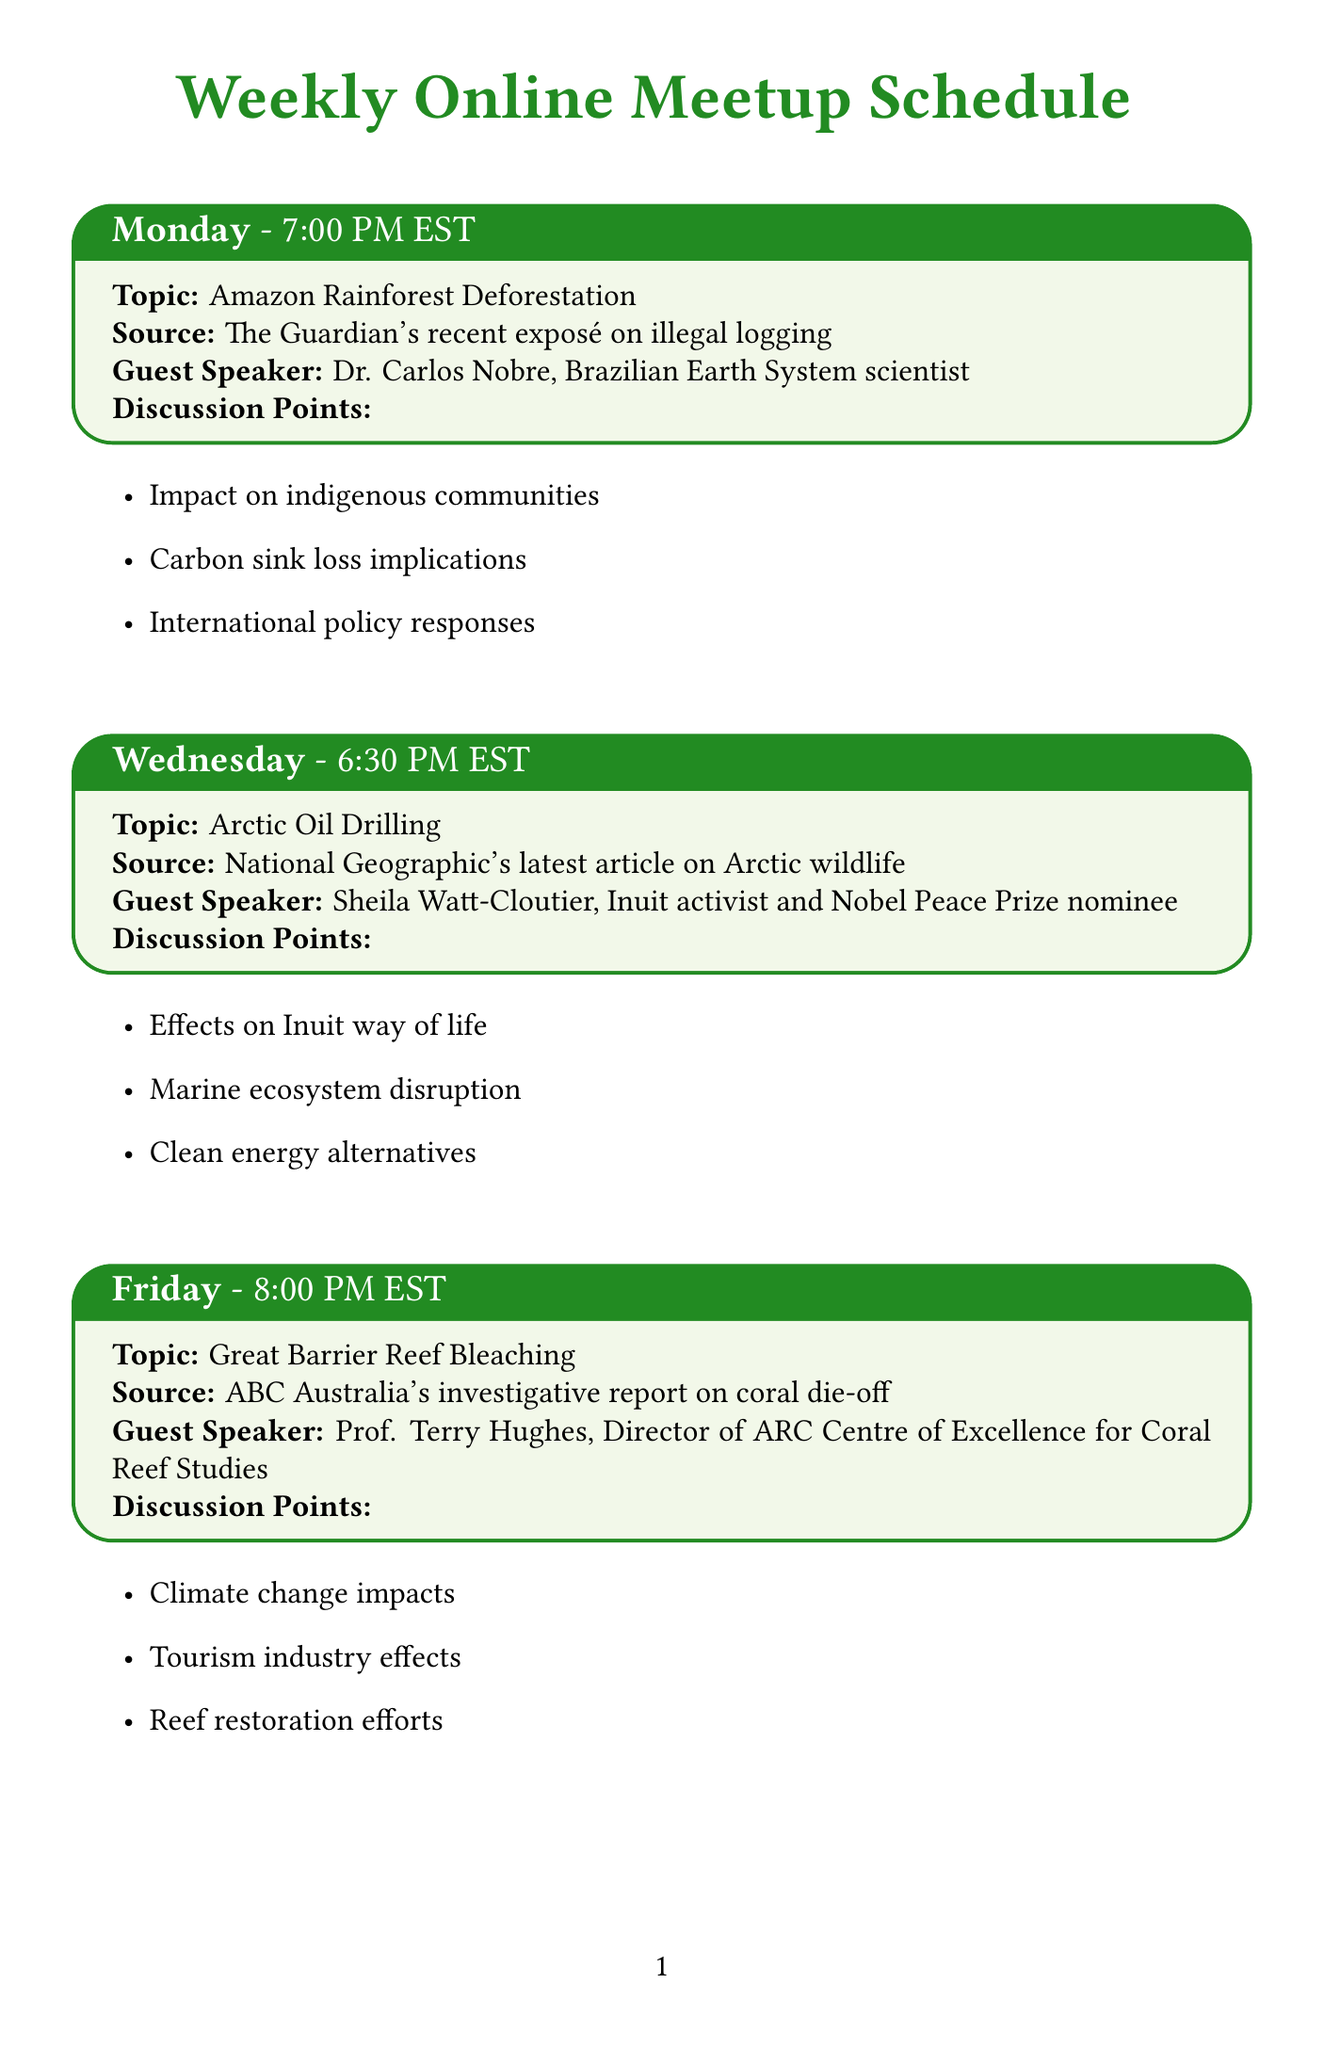What is the topic of the meeting on Friday? The topic for Friday's meeting is listed in the schedule as "Great Barrier Reef Bleaching."
Answer: Great Barrier Reef Bleaching Who is the guest speaker for the discussion on Renewable Energy in Developing Nations? The schedule specifies that Damilola Ogunbiyi, CEO of Sustainable Energy for All, will be the guest speaker for this discussion.
Answer: Damilola Ogunbiyi What time does the Arctic Oil Drilling discussion take place? The schedule indicates that the Arctic Oil Drilling discussion is on Wednesday at 6:30 PM EST.
Answer: 6:30 PM EST What is the current focus of the Petition Drive initiative? The document states that the current focus of the Petition Drive is to "Stop fossil fuel subsidies."
Answer: Stop fossil fuel subsidies When is the next Digital Storytelling Workshop? According to the document, the next workshop is scheduled for July 15, 2023.
Answer: 2023-07-15 What type of event is happening on July 29, 2023? The document mentions a screening for the Documentary Club occurring on that date.
Answer: Documentary Club Which book is included in the Reading List curated by Bill McKibben? The schedule lists "Silent Spring by Rachel Carson" as one of the current recommendations in the Reading List.
Answer: Silent Spring by Rachel Carson Who will lead the Data Visualization Tools workshop? Eric Holthaus is mentioned as the leader for the Data Visualization Tools workshop.
Answer: Eric Holthaus What is a potential topic for discussion related to the Great Barrier Reef Bleaching? One of the discussion points for this meeting includes "Tourism industry effects," as listed in the schedule.
Answer: Tourism industry effects 